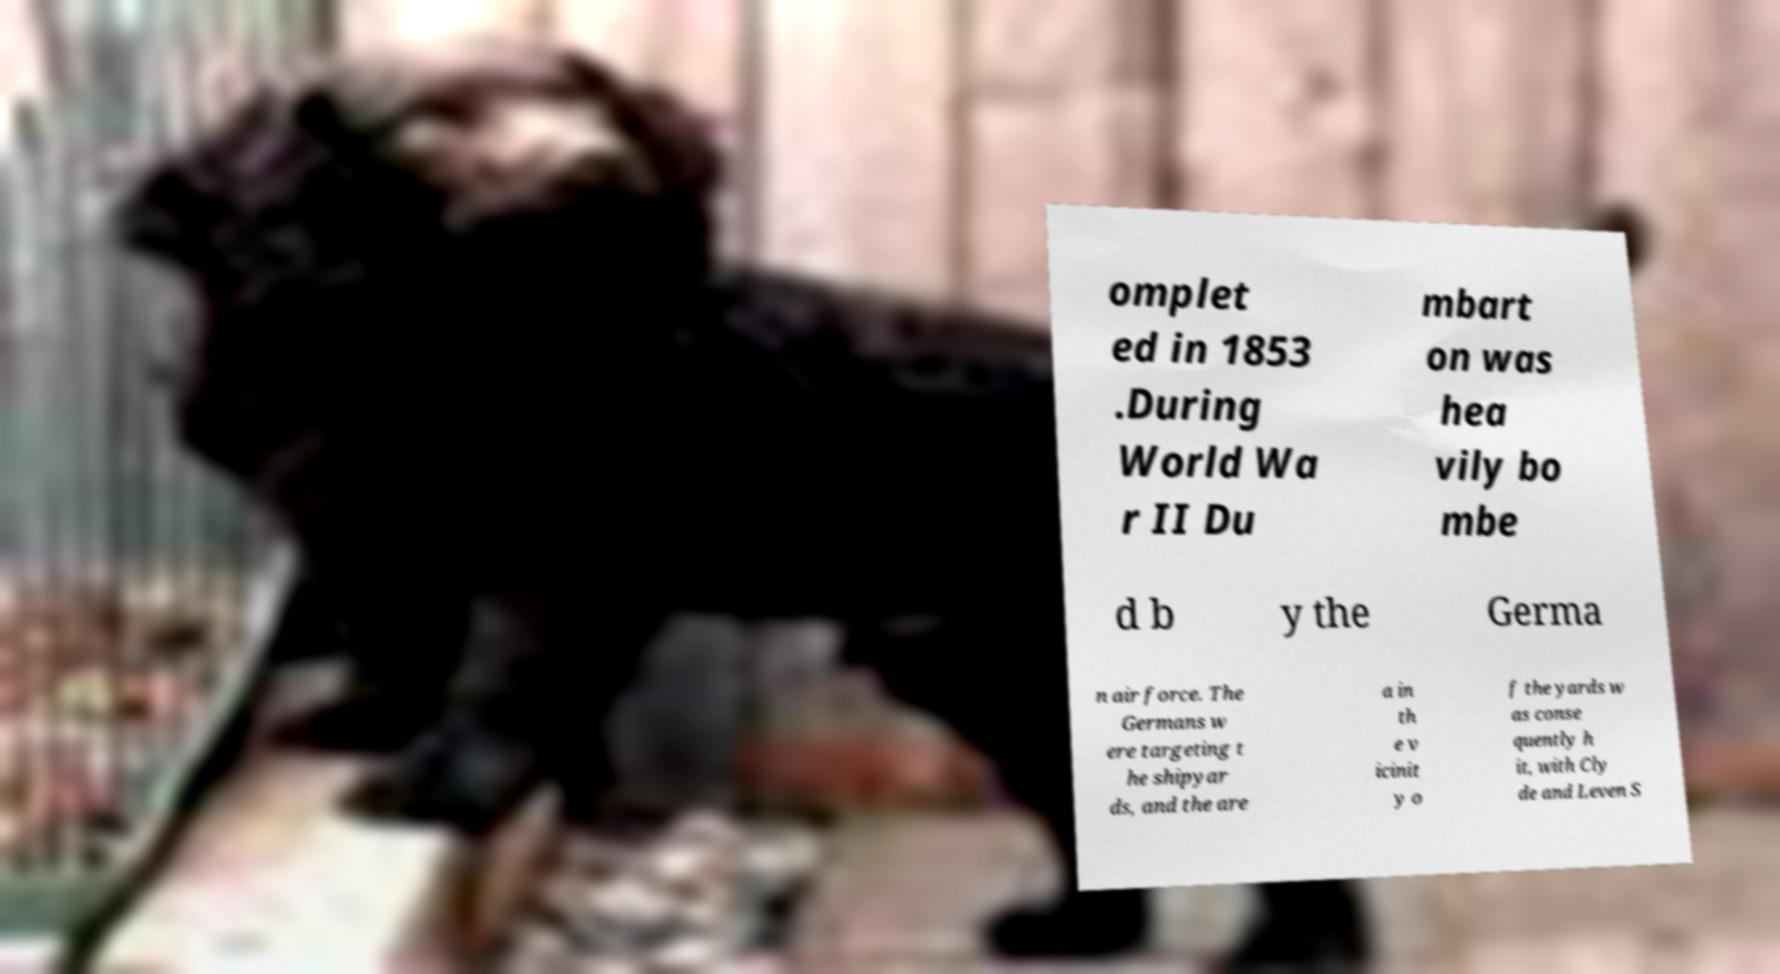What messages or text are displayed in this image? I need them in a readable, typed format. omplet ed in 1853 .During World Wa r II Du mbart on was hea vily bo mbe d b y the Germa n air force. The Germans w ere targeting t he shipyar ds, and the are a in th e v icinit y o f the yards w as conse quently h it, with Cly de and Leven S 